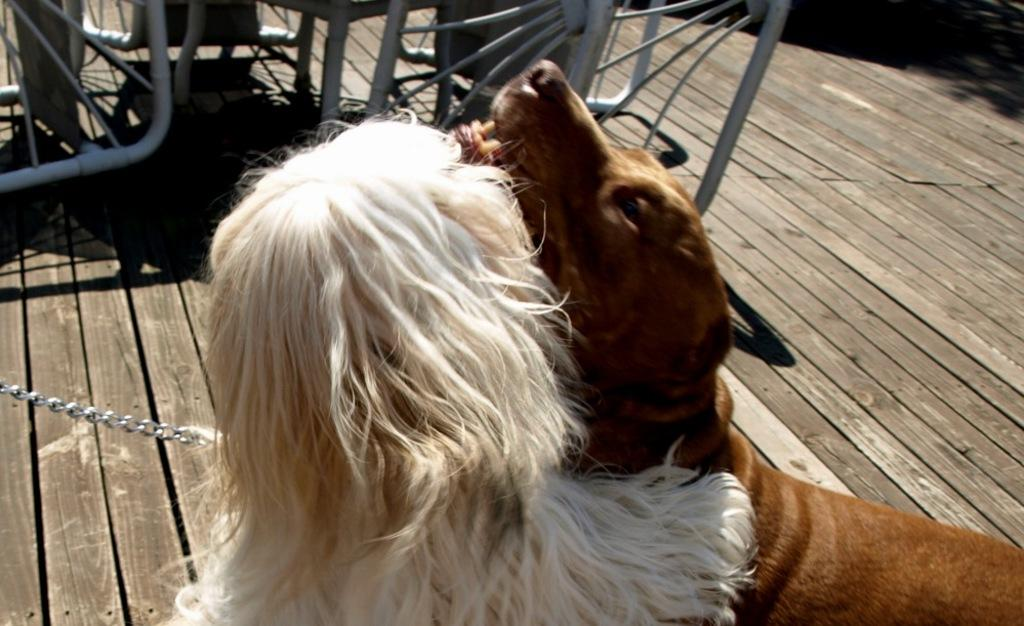What animals can be seen in the foreground of the picture? There are two dogs in the foreground of the picture. What type of flooring is visible beneath the dogs? The dogs are on a wooden floor. What objects can be seen at the top of the image? There are iron objects resembling benches at the top of the image. What is located on the left side of the image? There is an iron chain on the left side of the image. What type of linen is draped over the dogs in the image? There is no linen present in the image; the dogs are not covered by any fabric. 